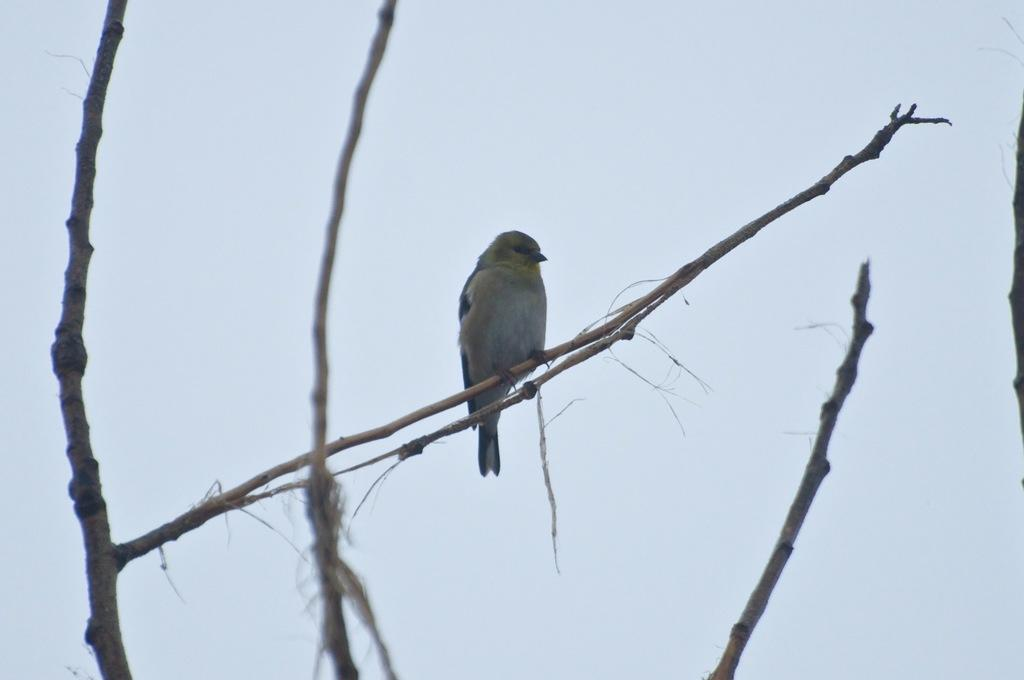What type of animal is in the image? There is a bird in the image. Where is the bird located? The bird is on a branch. What color is the background of the image? The background of the image is white. What letter can be seen in the bird's hand in the image? There is no letter or hand present in the image; it only features a bird on a branch with a white background. 